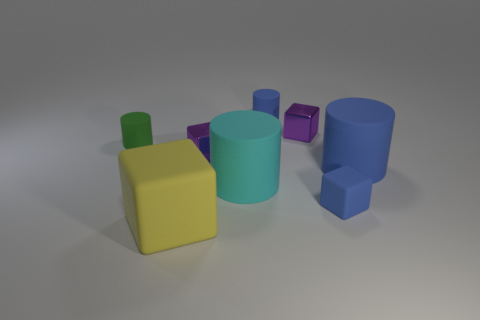There is a tiny blue matte object behind the rubber block that is to the right of the big matte cube; what is its shape? cylinder 